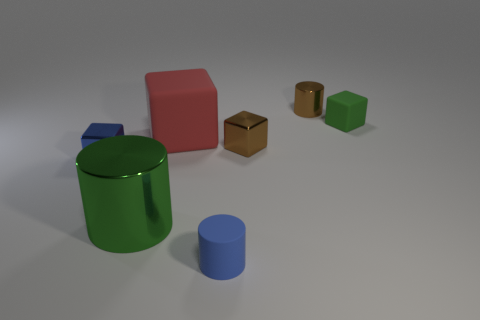There is a tiny thing that is the same color as the large shiny cylinder; what is its material?
Your response must be concise. Rubber. How many large red objects are to the right of the rubber cube on the right side of the small rubber cylinder?
Provide a succinct answer. 0. Is there another thing of the same shape as the green rubber thing?
Offer a very short reply. Yes. Does the green object that is in front of the large matte object have the same shape as the matte thing in front of the small blue metal block?
Provide a succinct answer. Yes. What number of things are brown cylinders or big red cubes?
Your answer should be very brief. 2. The other brown thing that is the same shape as the big shiny thing is what size?
Provide a succinct answer. Small. Are there more small blue cylinders right of the tiny blue block than red rubber blocks?
Make the answer very short. No. Does the large green cylinder have the same material as the big red object?
Offer a terse response. No. How many things are small cylinders behind the brown block or things that are on the left side of the big red matte thing?
Provide a succinct answer. 3. The small shiny thing that is the same shape as the large green shiny thing is what color?
Your answer should be very brief. Brown. 